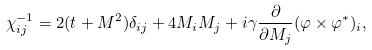<formula> <loc_0><loc_0><loc_500><loc_500>\chi ^ { - 1 } _ { i j } = 2 ( t + M ^ { 2 } ) \delta _ { i j } + 4 M _ { i } M _ { j } + i \gamma \frac { \partial } { \partial M _ { j } } ( \varphi \times \varphi ^ { \ast } ) _ { i } ,</formula> 